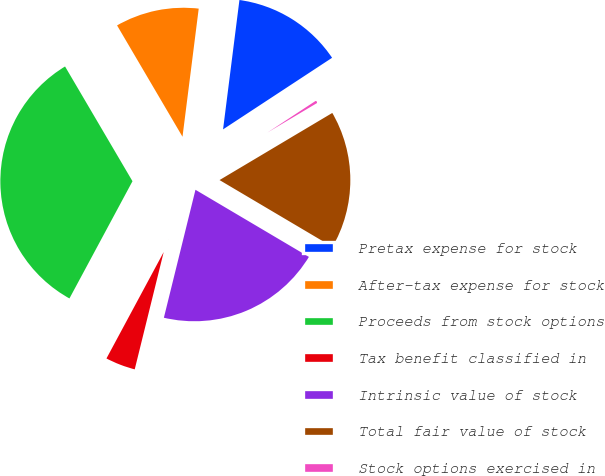<chart> <loc_0><loc_0><loc_500><loc_500><pie_chart><fcel>Pretax expense for stock<fcel>After-tax expense for stock<fcel>Proceeds from stock options<fcel>Tax benefit classified in<fcel>Intrinsic value of stock<fcel>Total fair value of stock<fcel>Stock options exercised in<nl><fcel>13.75%<fcel>10.46%<fcel>33.69%<fcel>4.0%<fcel>20.35%<fcel>17.05%<fcel>0.7%<nl></chart> 